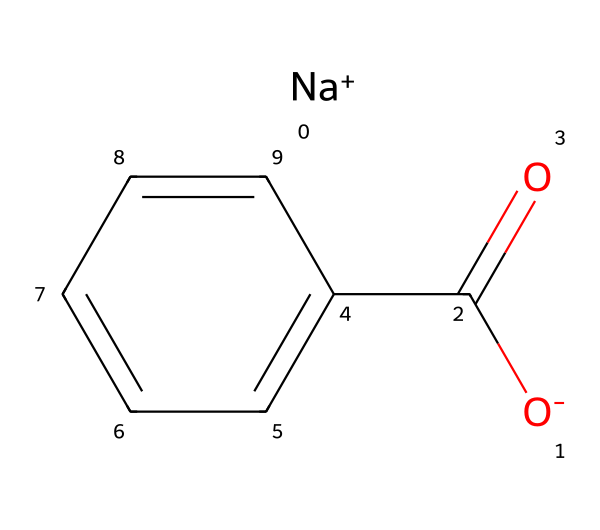What is the chemical name of this compound? The SMILES representation indicates the presence of sodium (Na) and a benzoic acid derivative, which is known as sodium benzoate.
Answer: sodium benzoate How many carbon atoms are in sodium benzoate? By analyzing the structure, we can count that there are seven carbon atoms present, including the benzene ring and the carbon in the carboxylate group.
Answer: 7 What type of functional group is present in sodium benzoate? The presence of the carboxylate group (represented by -C(=O)[O-]) indicates that sodium benzoate contains a carboxylate functional group, which is characteristic of salts of carboxylic acids.
Answer: carboxylate What is the total number of oxygen atoms in the structure? In the structure, there are two oxygen atoms: one in the carboxylate group and another in the carbonyl part of the same group.
Answer: 2 Is sodium benzoate soluble in water? Sodium benzoate is a salt derived from the reaction of benzoic acid and sodium hydroxide, and salts like it are generally soluble in water due to their ionic nature.
Answer: yes What effect does sodium benzoate have in food preservation? Sodium benzoate acts as a preservative by inhibiting the growth of bacteria, yeast, and fungi, thereby extending the shelf life of food products.
Answer: inhibit microbial growth What ionic charge does sodium have in sodium benzoate? The structure shows sodium with a positive charge denoted by [Na+], indicating that it exists as a cation in the compound.
Answer: positive 